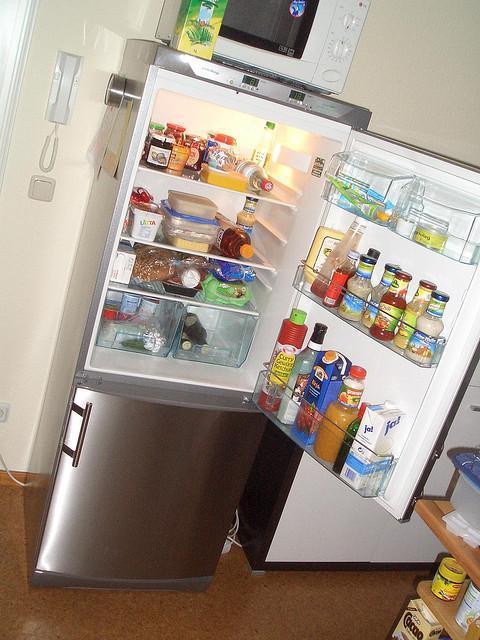How many bottles are in the picture?
Give a very brief answer. 3. 